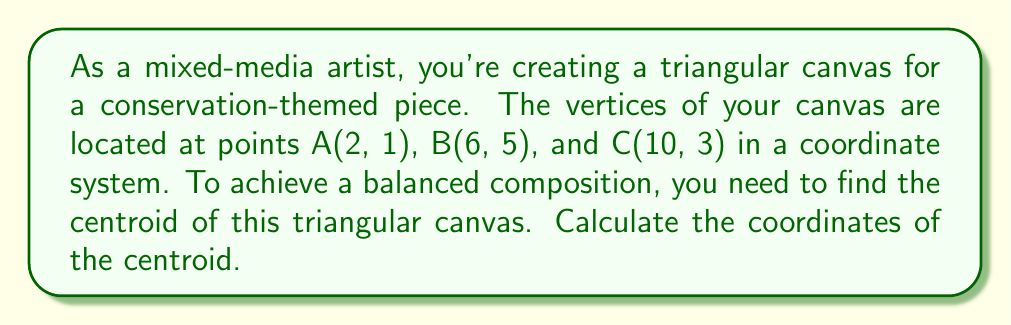Give your solution to this math problem. To find the centroid of a triangle, we can follow these steps:

1. The centroid formula for a triangle with vertices $(x_1, y_1)$, $(x_2, y_2)$, and $(x_3, y_3)$ is:

   $$\left(\frac{x_1 + x_2 + x_3}{3}, \frac{y_1 + y_2 + y_3}{3}\right)$$

2. In this case, we have:
   A(2, 1), B(6, 5), and C(10, 3)

   So, $x_1 = 2$, $y_1 = 1$
       $x_2 = 6$, $y_2 = 5$
       $x_3 = 10$, $y_3 = 3$

3. Let's calculate the x-coordinate of the centroid:
   $$x = \frac{x_1 + x_2 + x_3}{3} = \frac{2 + 6 + 10}{3} = \frac{18}{3} = 6$$

4. Now, let's calculate the y-coordinate of the centroid:
   $$y = \frac{y_1 + y_2 + y_3}{3} = \frac{1 + 5 + 3}{3} = \frac{9}{3} = 3$$

5. Therefore, the coordinates of the centroid are (6, 3).

[asy]
unitsize(0.5cm);
pair A = (2,1);
pair B = (6,5);
pair C = (10,3);
pair G = (6,3);

draw(A--B--C--cycle);
dot(A);
dot(B);
dot(C);
dot(G,red);

label("A", A, SW);
label("B", B, N);
label("C", C, SE);
label("G", G, E);

xaxis(0,12,arrow=Arrow);
yaxis(0,6,arrow=Arrow);
[/asy]
Answer: (6, 3) 